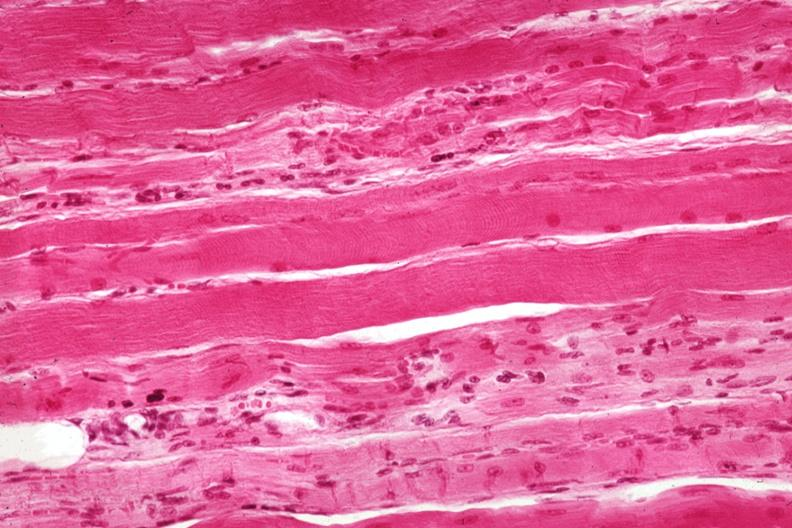s muscle present?
Answer the question using a single word or phrase. Yes 